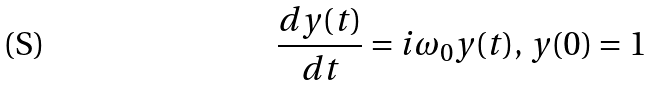Convert formula to latex. <formula><loc_0><loc_0><loc_500><loc_500>\frac { d y ( t ) } { d t } = i \omega _ { 0 } y ( t ) , \, y ( 0 ) = 1</formula> 